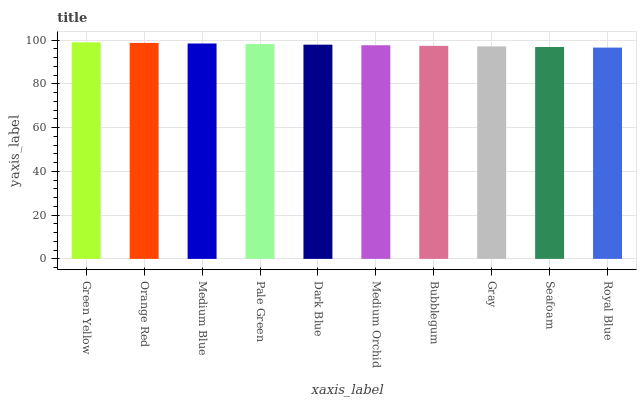Is Royal Blue the minimum?
Answer yes or no. Yes. Is Green Yellow the maximum?
Answer yes or no. Yes. Is Orange Red the minimum?
Answer yes or no. No. Is Orange Red the maximum?
Answer yes or no. No. Is Green Yellow greater than Orange Red?
Answer yes or no. Yes. Is Orange Red less than Green Yellow?
Answer yes or no. Yes. Is Orange Red greater than Green Yellow?
Answer yes or no. No. Is Green Yellow less than Orange Red?
Answer yes or no. No. Is Dark Blue the high median?
Answer yes or no. Yes. Is Medium Orchid the low median?
Answer yes or no. Yes. Is Seafoam the high median?
Answer yes or no. No. Is Gray the low median?
Answer yes or no. No. 